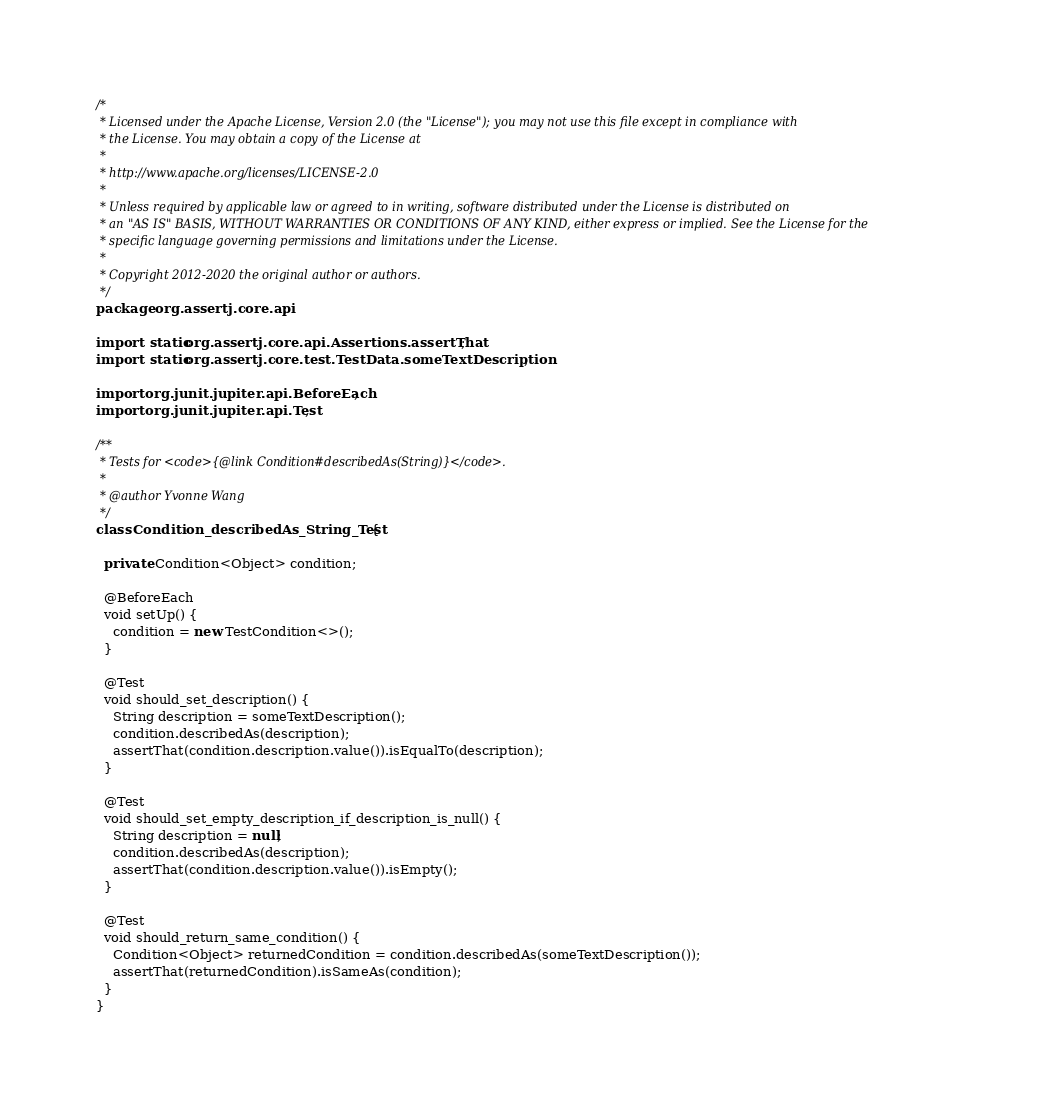<code> <loc_0><loc_0><loc_500><loc_500><_Java_>/*
 * Licensed under the Apache License, Version 2.0 (the "License"); you may not use this file except in compliance with
 * the License. You may obtain a copy of the License at
 *
 * http://www.apache.org/licenses/LICENSE-2.0
 *
 * Unless required by applicable law or agreed to in writing, software distributed under the License is distributed on
 * an "AS IS" BASIS, WITHOUT WARRANTIES OR CONDITIONS OF ANY KIND, either express or implied. See the License for the
 * specific language governing permissions and limitations under the License.
 *
 * Copyright 2012-2020 the original author or authors.
 */
package org.assertj.core.api;

import static org.assertj.core.api.Assertions.assertThat;
import static org.assertj.core.test.TestData.someTextDescription;

import org.junit.jupiter.api.BeforeEach;
import org.junit.jupiter.api.Test;

/**
 * Tests for <code>{@link Condition#describedAs(String)}</code>.
 * 
 * @author Yvonne Wang
 */
class Condition_describedAs_String_Test {

  private Condition<Object> condition;

  @BeforeEach
  void setUp() {
    condition = new TestCondition<>();
  }

  @Test
  void should_set_description() {
    String description = someTextDescription();
    condition.describedAs(description);
    assertThat(condition.description.value()).isEqualTo(description);
  }

  @Test
  void should_set_empty_description_if_description_is_null() {
    String description = null;
    condition.describedAs(description);
    assertThat(condition.description.value()).isEmpty();
  }

  @Test
  void should_return_same_condition() {
    Condition<Object> returnedCondition = condition.describedAs(someTextDescription());
    assertThat(returnedCondition).isSameAs(condition);
  }
}
</code> 